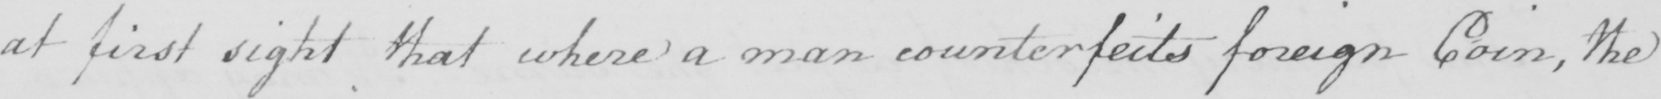What is written in this line of handwriting? at first sight that where a man counterfeits foreign Coin , the 